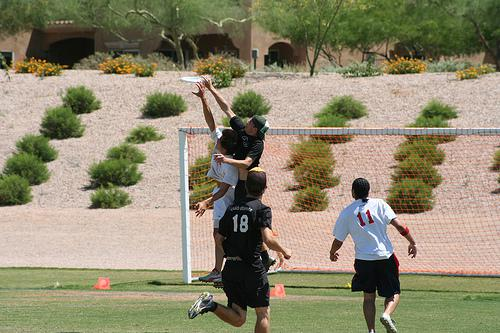Question: where was the photo taken?
Choices:
A. At a game.
B. On the playing field.
C. At the movies.
D. At a picnic.
Answer with the letter. Answer: B Question: what is green?
Choices:
A. Grass.
B. Sign.
C. Shirt.
D. Car.
Answer with the letter. Answer: A Question: how many people are there?
Choices:
A. Eight.
B. Four.
C. Seven.
D. Three.
Answer with the letter. Answer: B Question: who is wearing white?
Choices:
A. The coach.
B. Two players.
C. One man.
D. One woman.
Answer with the letter. Answer: B Question: what is yellow?
Choices:
A. Bananas.
B. Flowers.
C. Buses.
D. Pencils.
Answer with the letter. Answer: B 